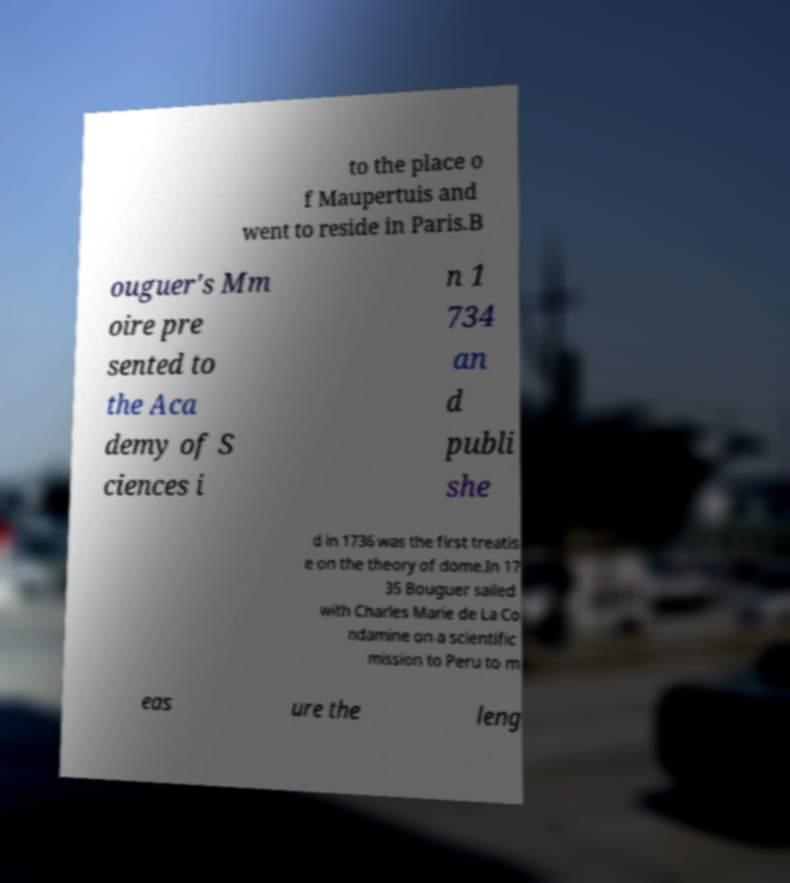Please identify and transcribe the text found in this image. to the place o f Maupertuis and went to reside in Paris.B ouguer's Mm oire pre sented to the Aca demy of S ciences i n 1 734 an d publi she d in 1736 was the first treatis e on the theory of dome.In 17 35 Bouguer sailed with Charles Marie de La Co ndamine on a scientific mission to Peru to m eas ure the leng 